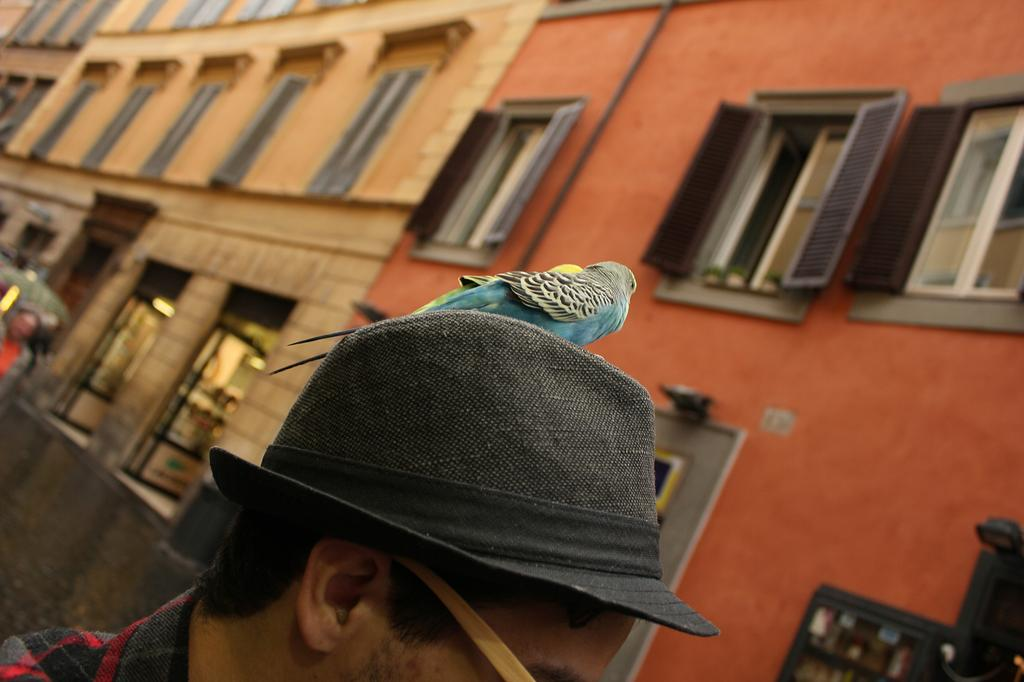What is the person in the image wearing on their head? The person in the image is wearing a hat. What type of animal can be seen in the image? There is a bird in the image. What can be seen in the background of the image? There are buildings and windows in the background of the image. How many people are visible in the image? There is at least one other person in the background of the image, in addition to the person wearing the hat. What color is the cherry that the person is holding in the image? There is no cherry present in the image; the person is wearing a hat and there is a bird visible. 